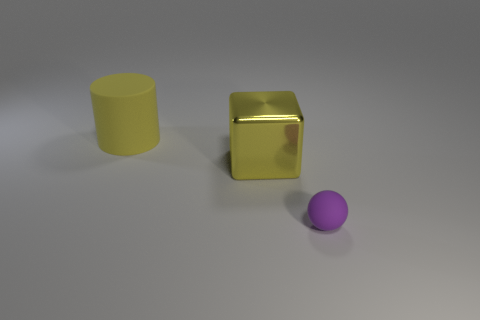Is there anything else that is the same size as the sphere?
Offer a very short reply. No. There is a big rubber object; are there any large yellow things to the right of it?
Keep it short and to the point. Yes. Is the shape of the large matte object the same as the yellow metal thing?
Provide a succinct answer. No. How big is the yellow object that is on the left side of the big object that is in front of the matte thing that is behind the sphere?
Offer a very short reply. Large. What material is the small thing?
Provide a short and direct response. Rubber. What is the size of the matte object that is the same color as the block?
Give a very brief answer. Large. Does the big shiny object have the same shape as the rubber thing behind the rubber sphere?
Make the answer very short. No. What is the material of the sphere that is on the right side of the yellow thing in front of the rubber thing that is behind the purple object?
Give a very brief answer. Rubber. How many tiny gray rubber cubes are there?
Ensure brevity in your answer.  0. How many purple objects are big matte things or tiny things?
Offer a terse response. 1. 